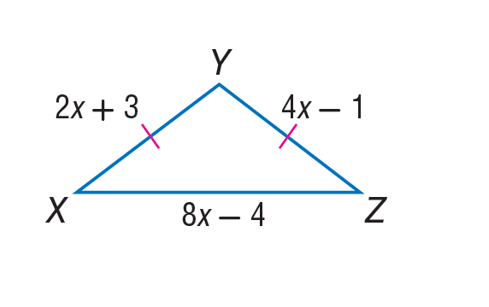Answer the mathemtical geometry problem and directly provide the correct option letter.
Question: Find X Z of isosceles \triangle X Y Z.
Choices: A: 7 B: 8 C: 12 D: 16 C 